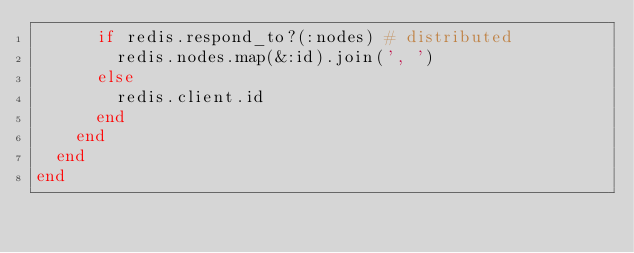<code> <loc_0><loc_0><loc_500><loc_500><_Ruby_>      if redis.respond_to?(:nodes) # distributed
        redis.nodes.map(&:id).join(', ')
      else
        redis.client.id
      end
    end
  end
end
</code> 